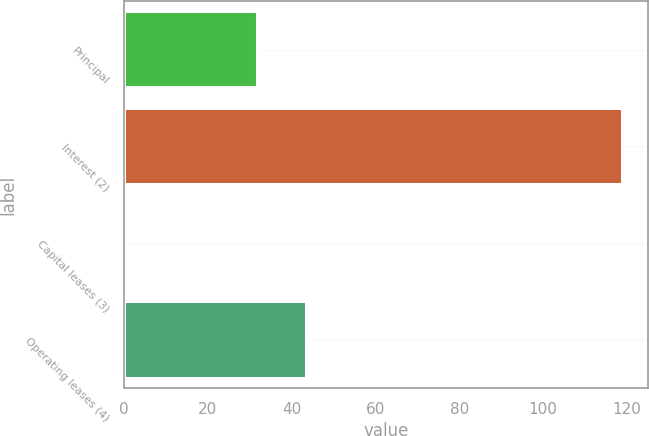Convert chart to OTSL. <chart><loc_0><loc_0><loc_500><loc_500><bar_chart><fcel>Principal<fcel>Interest (2)<fcel>Capital leases (3)<fcel>Operating leases (4)<nl><fcel>32<fcel>119<fcel>0.8<fcel>43.82<nl></chart> 